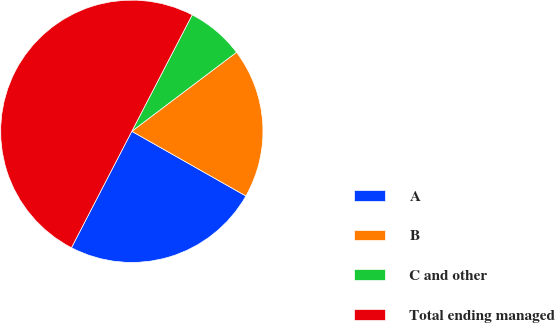Convert chart. <chart><loc_0><loc_0><loc_500><loc_500><pie_chart><fcel>A<fcel>B<fcel>C and other<fcel>Total ending managed<nl><fcel>24.4%<fcel>18.5%<fcel>7.1%<fcel>50.0%<nl></chart> 